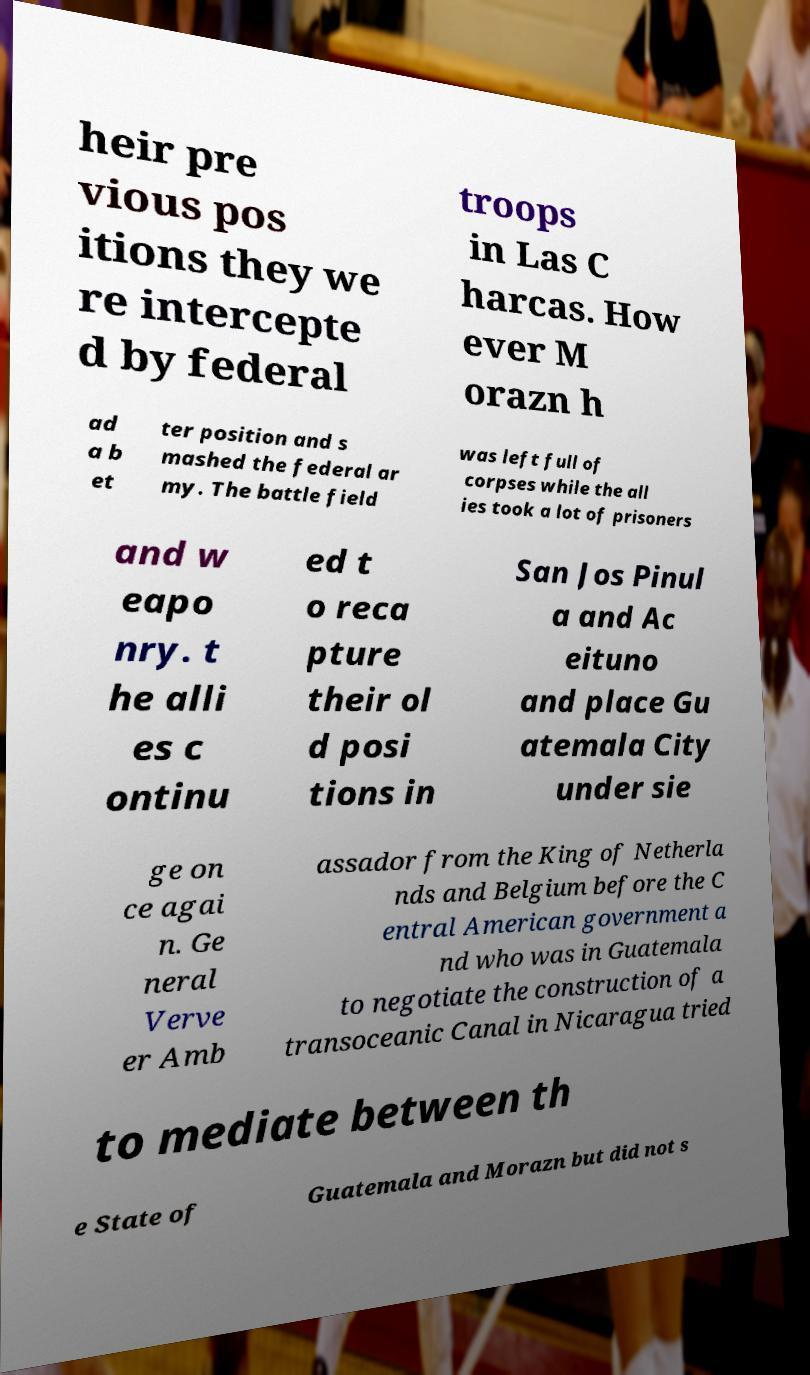Can you read and provide the text displayed in the image?This photo seems to have some interesting text. Can you extract and type it out for me? heir pre vious pos itions they we re intercepte d by federal troops in Las C harcas. How ever M orazn h ad a b et ter position and s mashed the federal ar my. The battle field was left full of corpses while the all ies took a lot of prisoners and w eapo nry. t he alli es c ontinu ed t o reca pture their ol d posi tions in San Jos Pinul a and Ac eituno and place Gu atemala City under sie ge on ce agai n. Ge neral Verve er Amb assador from the King of Netherla nds and Belgium before the C entral American government a nd who was in Guatemala to negotiate the construction of a transoceanic Canal in Nicaragua tried to mediate between th e State of Guatemala and Morazn but did not s 